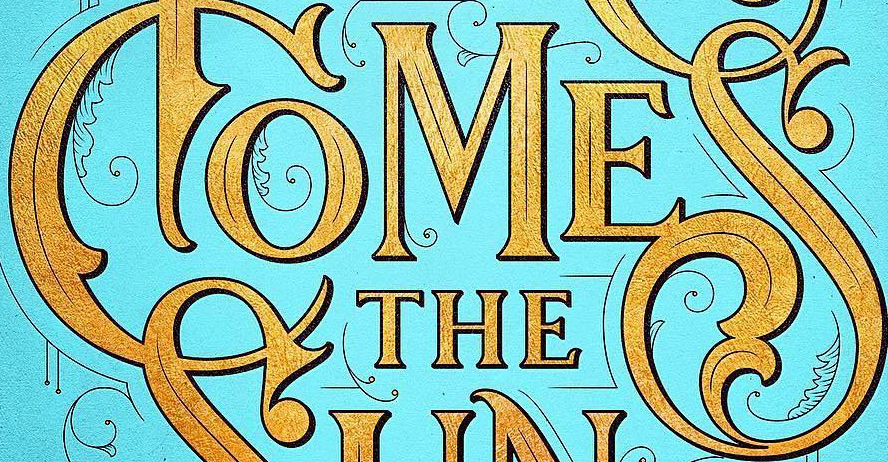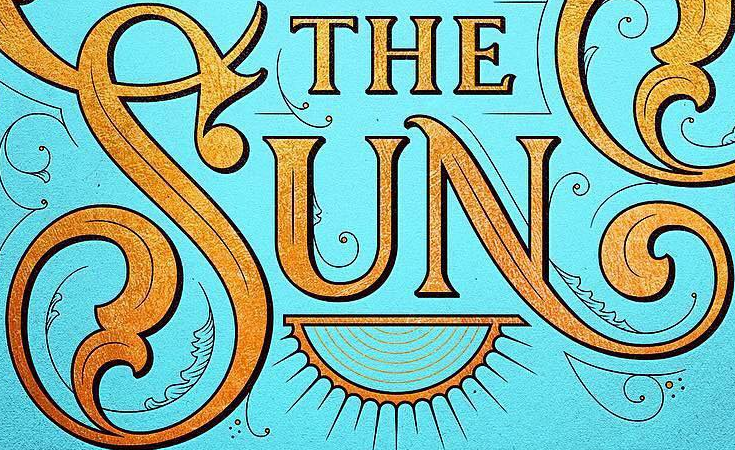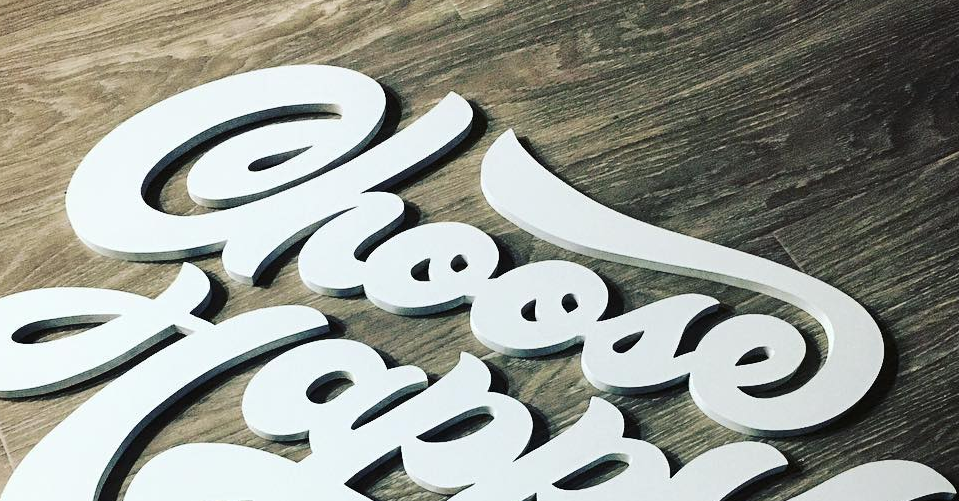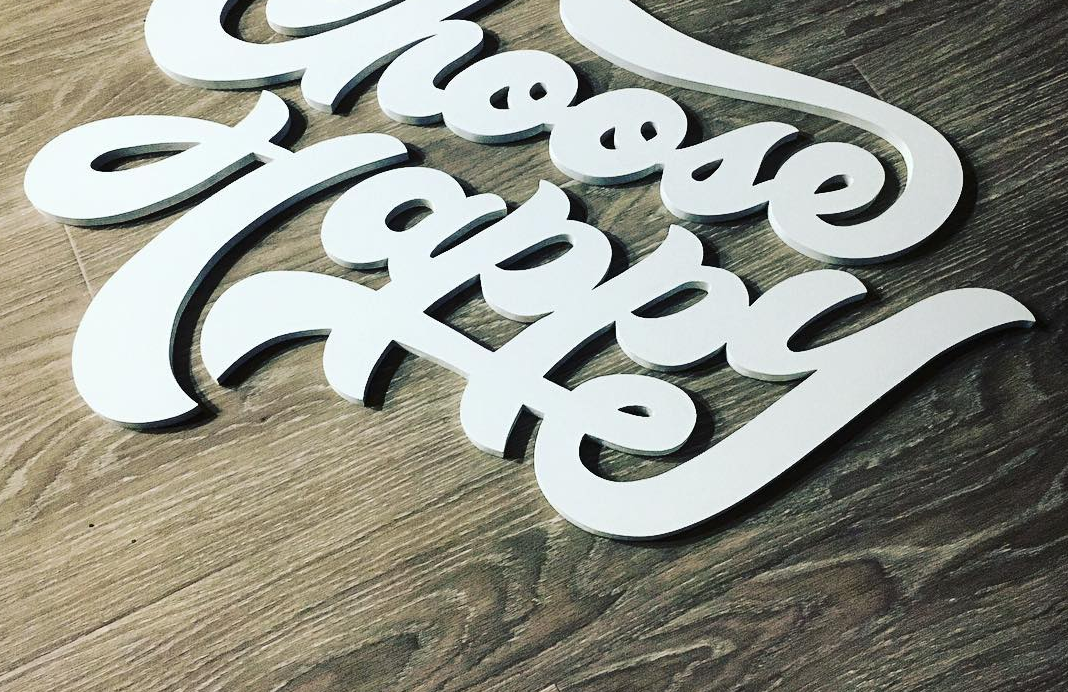What text appears in these images from left to right, separated by a semicolon? COMES; SUN; Choose; Happy 